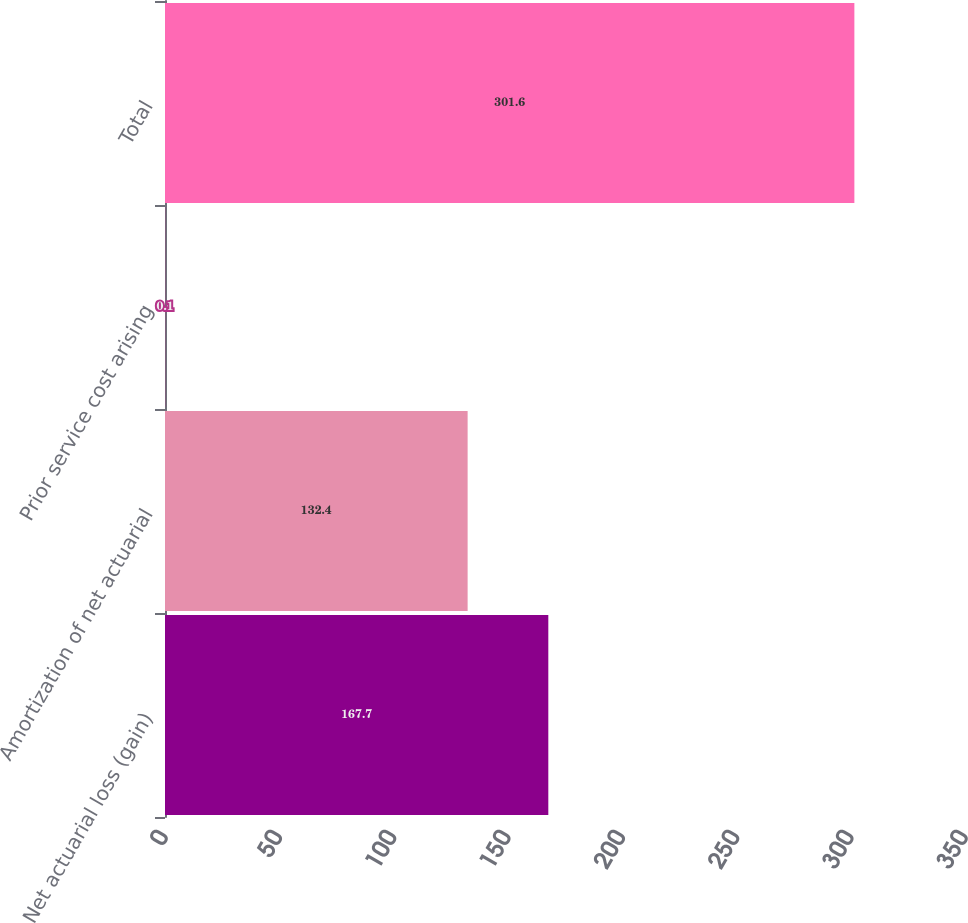Convert chart. <chart><loc_0><loc_0><loc_500><loc_500><bar_chart><fcel>Net actuarial loss (gain)<fcel>Amortization of net actuarial<fcel>Prior service cost arising<fcel>Total<nl><fcel>167.7<fcel>132.4<fcel>0.1<fcel>301.6<nl></chart> 